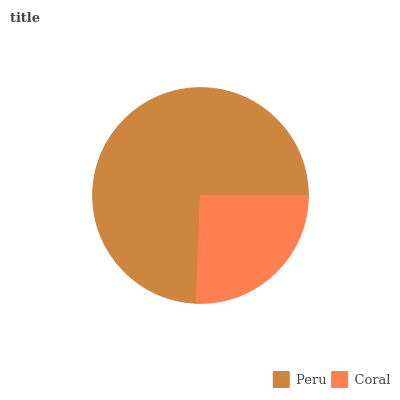Is Coral the minimum?
Answer yes or no. Yes. Is Peru the maximum?
Answer yes or no. Yes. Is Coral the maximum?
Answer yes or no. No. Is Peru greater than Coral?
Answer yes or no. Yes. Is Coral less than Peru?
Answer yes or no. Yes. Is Coral greater than Peru?
Answer yes or no. No. Is Peru less than Coral?
Answer yes or no. No. Is Peru the high median?
Answer yes or no. Yes. Is Coral the low median?
Answer yes or no. Yes. Is Coral the high median?
Answer yes or no. No. Is Peru the low median?
Answer yes or no. No. 